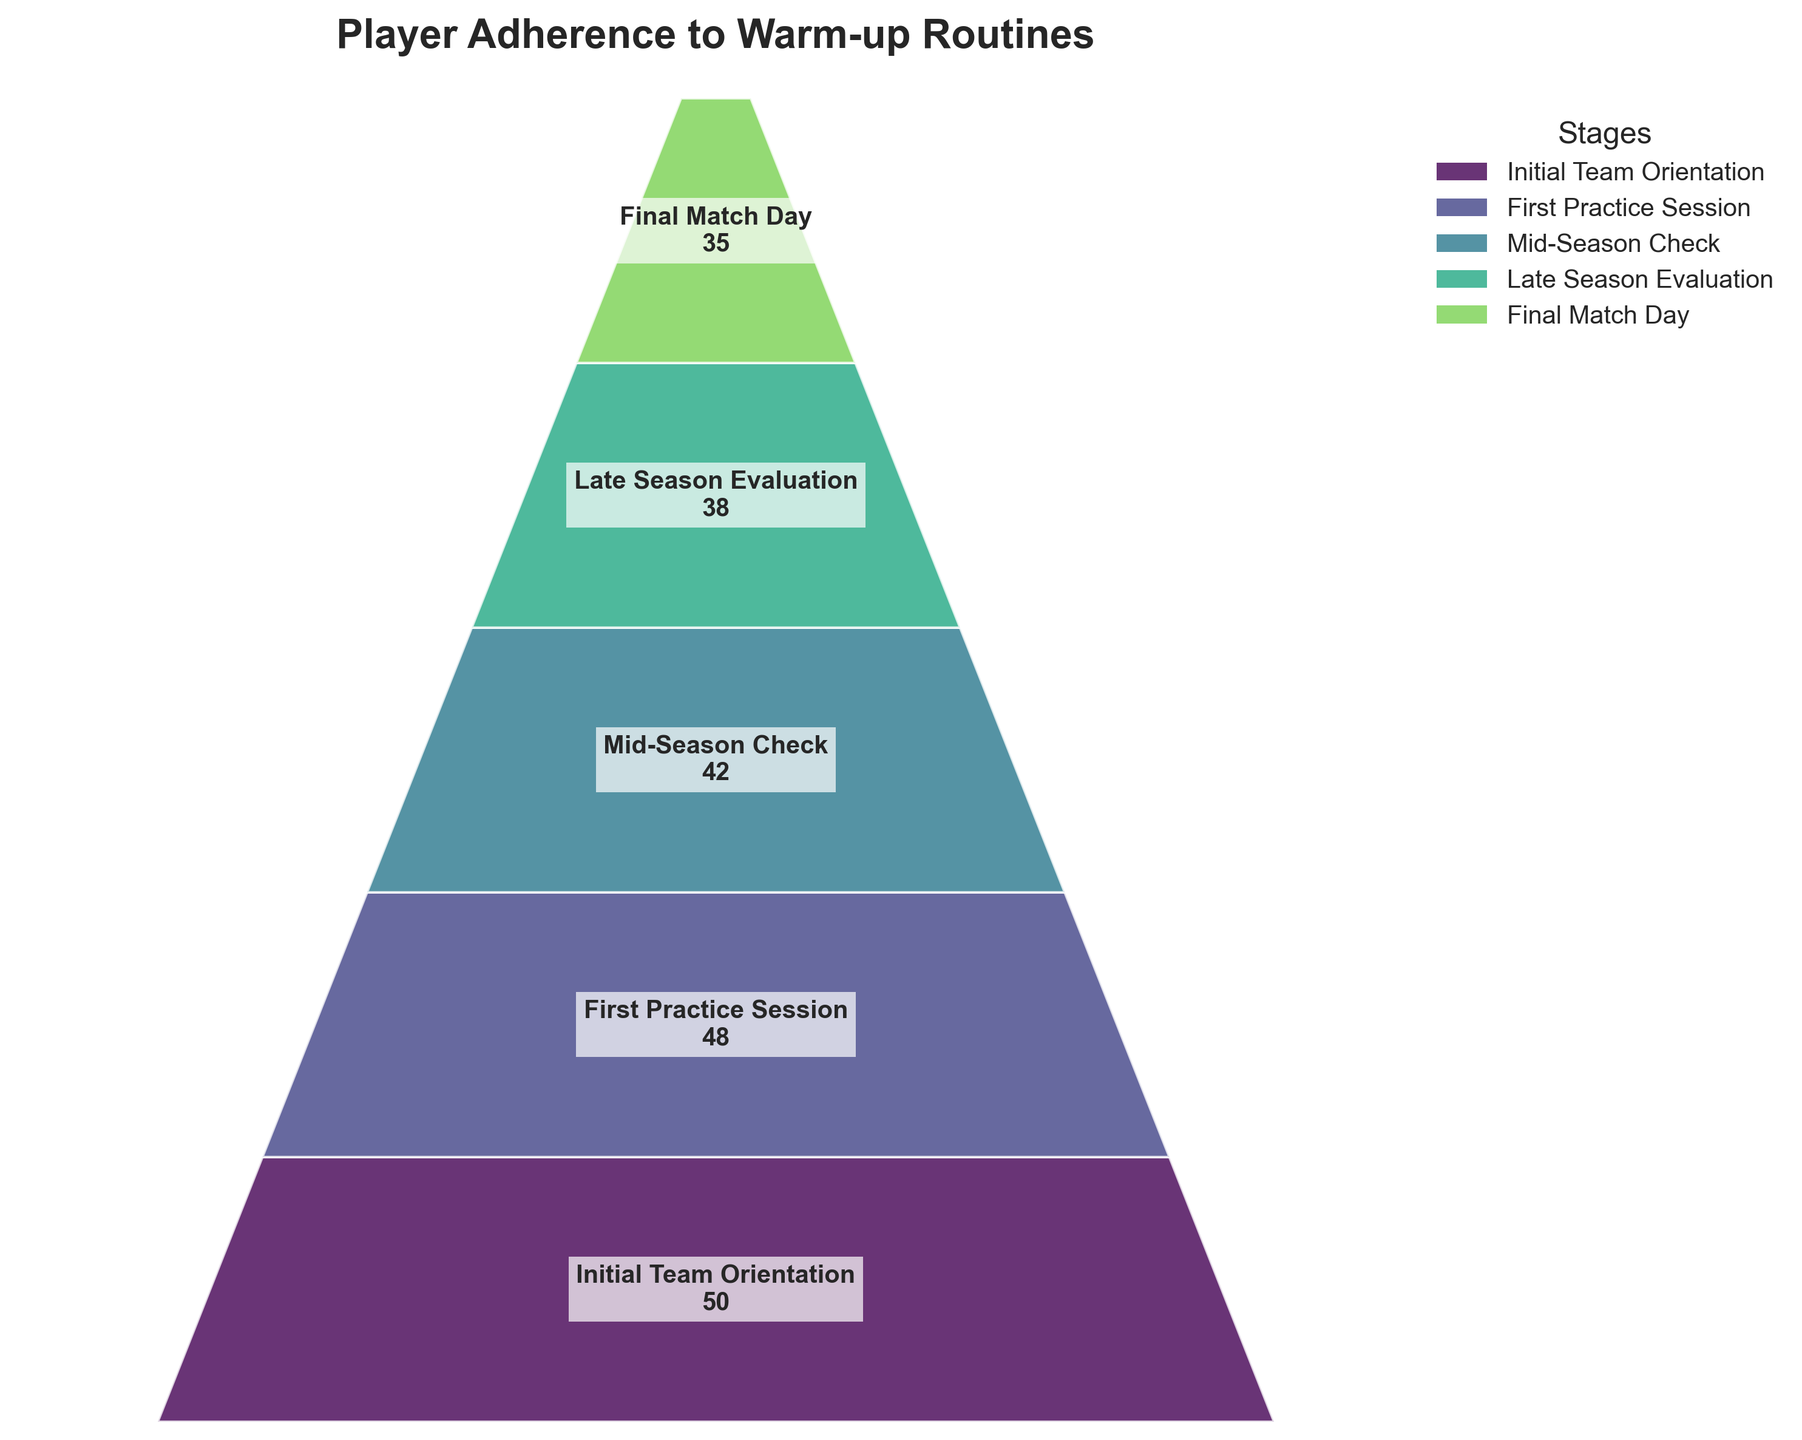What's the title of the figure? The title of the figure is usually located at the top of the chart and summarizes the main topic of the graph. As seen in the figure, the title is "Player Adherence to Warm-up Routines".
Answer: Player Adherence to Warm-up Routines How many stages are shown in the funnel chart? By counting the number of distinct stages mentioned within the funnel chart, we can see that there are five stages listed.
Answer: 5 What's the value for the "Final Match Day" stage? The value for each stage is displayed inside the particular segment on the funnel chart. The "Final Match Day" stage shows 35 players.
Answer: 35 Which stage has the second highest number of players? To determine the second highest number of players, we look for the second largest value among the different stages. The highest is at the "Initial Team Orientation" with 50 players, and the second highest is the "First Practice Session" with 48 players.
Answer: First Practice Session What is the decrease in the number of players from the "Mid-Season Check" to the "Final Match Day"? By subtracting the value of the "Final Match Day" stage from the "Mid-Season Check" stage, we get the decrease: 42 - 35 = 7.
Answer: 7 Which stage shows the largest drop in player count compared to the previous stage? To find the stage with the largest drop, we need to compare the differences between each consecutive stage. The differences are: Initial to First Practice (50-48=2), First Practice to Mid-Season (48-42=6), Mid-Season to Late Season (42-38=4), Late Season to Final Match (38-35=3). The largest difference is 6, between "First Practice Session" and "Mid-Season Check".
Answer: Mid-Season Check What is the total reduction in the number of players from "Initial Team Orientation" to "Final Match Day"? The total reduction is calculated by subtracting the "Final Match Day" value from the "Initial Team Orientation" value: 50 - 35 = 15.
Answer: 15 What percentage of players remained from the "Initial Team Orientation" to the "Final Match Day"? To find the percentage, we divide the number of players at "Final Match Day" by the number of players at "Initial Team Orientation" and multiply by 100: (35/50) * 100 = 70%.
Answer: 70% Between which stages is the player adherence rate the most consistent? We determine consistency by looking for the smallest decrease between stages: Initial to First Practice (2 players), First Practice to Mid-Season (6 players), Mid-Season to Late Season (4 players), Late Season to Final Match (3 players). The smallest drop is between "Initial Team Orientation" and "First Practice Session".
Answer: Initial Team Orientation and First Practice Session 